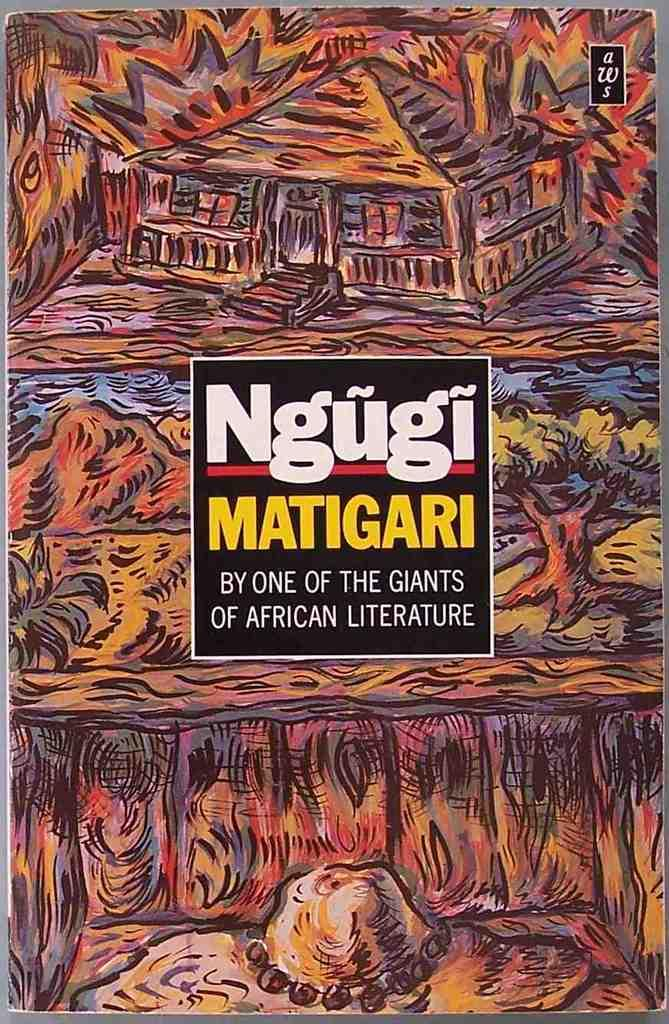<image>
Render a clear and concise summary of the photo. A colorful cover, Ngugi Matigari by one of the giants of African literature. 